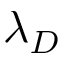Convert formula to latex. <formula><loc_0><loc_0><loc_500><loc_500>\lambda _ { D }</formula> 